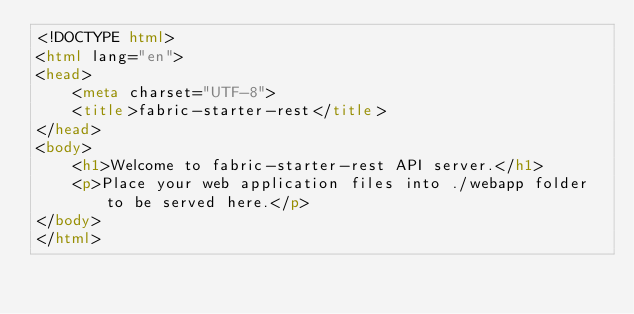<code> <loc_0><loc_0><loc_500><loc_500><_HTML_><!DOCTYPE html>
<html lang="en">
<head>
    <meta charset="UTF-8">
    <title>fabric-starter-rest</title>
</head>
<body>
    <h1>Welcome to fabric-starter-rest API server.</h1>
    <p>Place your web application files into ./webapp folder to be served here.</p>
</body>
</html>

</code> 